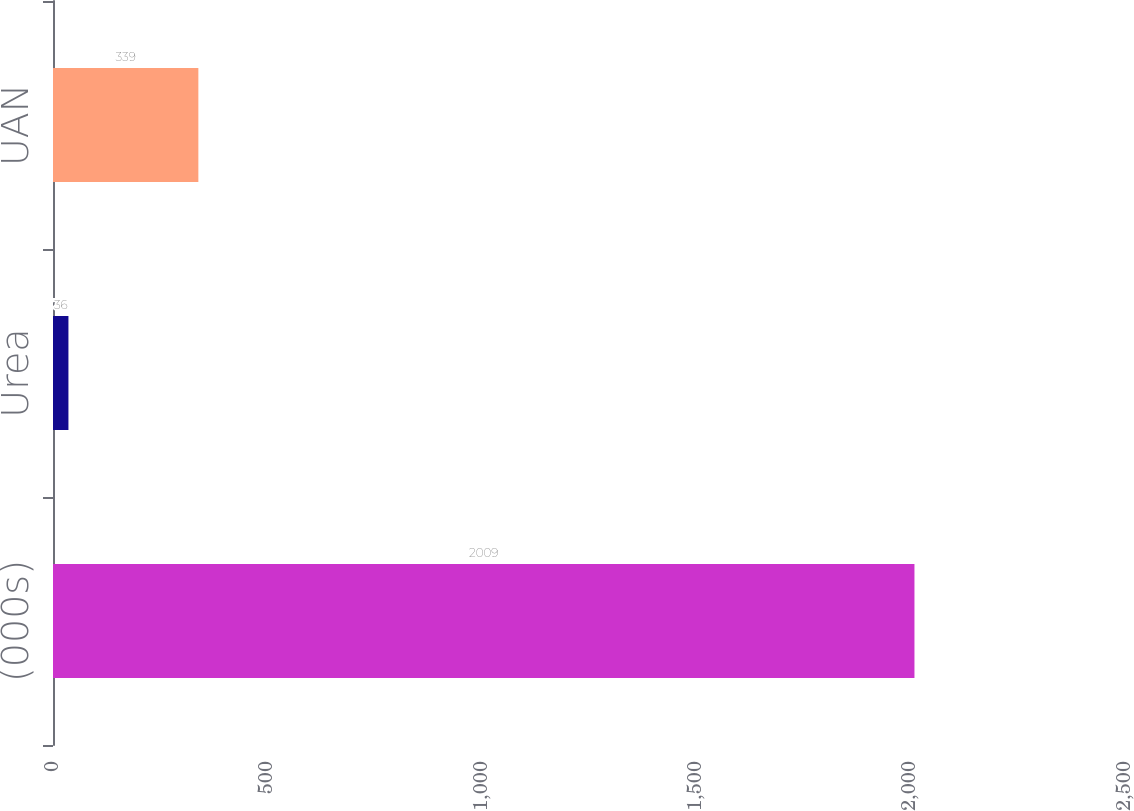Convert chart. <chart><loc_0><loc_0><loc_500><loc_500><bar_chart><fcel>(000s)<fcel>Urea<fcel>UAN<nl><fcel>2009<fcel>36<fcel>339<nl></chart> 